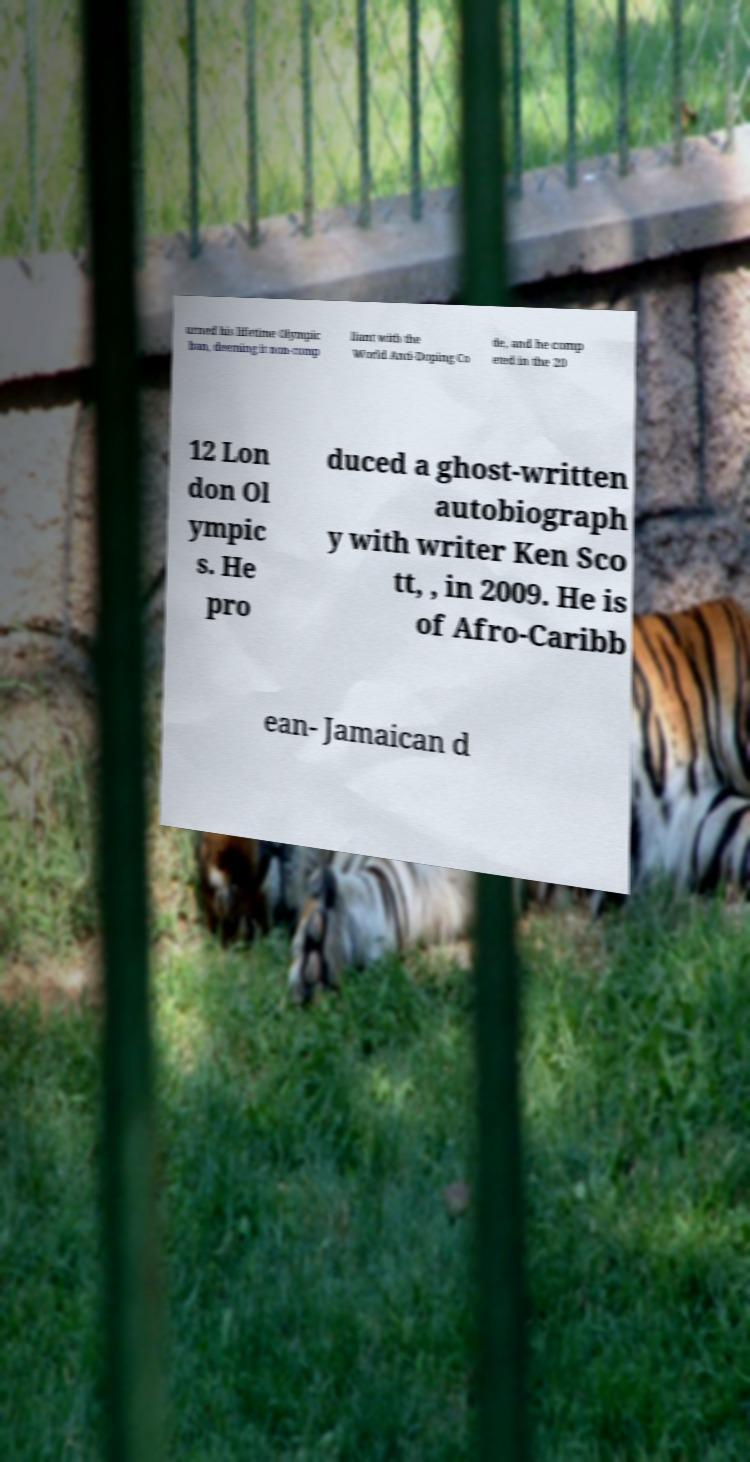There's text embedded in this image that I need extracted. Can you transcribe it verbatim? urned his lifetime Olympic ban, deeming it non-comp liant with the World Anti-Doping Co de, and he comp eted in the 20 12 Lon don Ol ympic s. He pro duced a ghost-written autobiograph y with writer Ken Sco tt, , in 2009. He is of Afro-Caribb ean- Jamaican d 